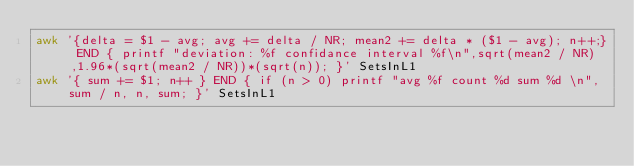<code> <loc_0><loc_0><loc_500><loc_500><_Bash_>awk '{delta = $1 - avg; avg += delta / NR; mean2 += delta * ($1 - avg); n++;} END { printf "deviation: %f confidance interval %f\n",sqrt(mean2 / NR),1.96*(sqrt(mean2 / NR))*(sqrt(n)); }' SetsInL1
awk '{ sum += $1; n++ } END { if (n > 0) printf "avg %f count %d sum %d \n",sum / n, n, sum; }' SetsInL1
</code> 